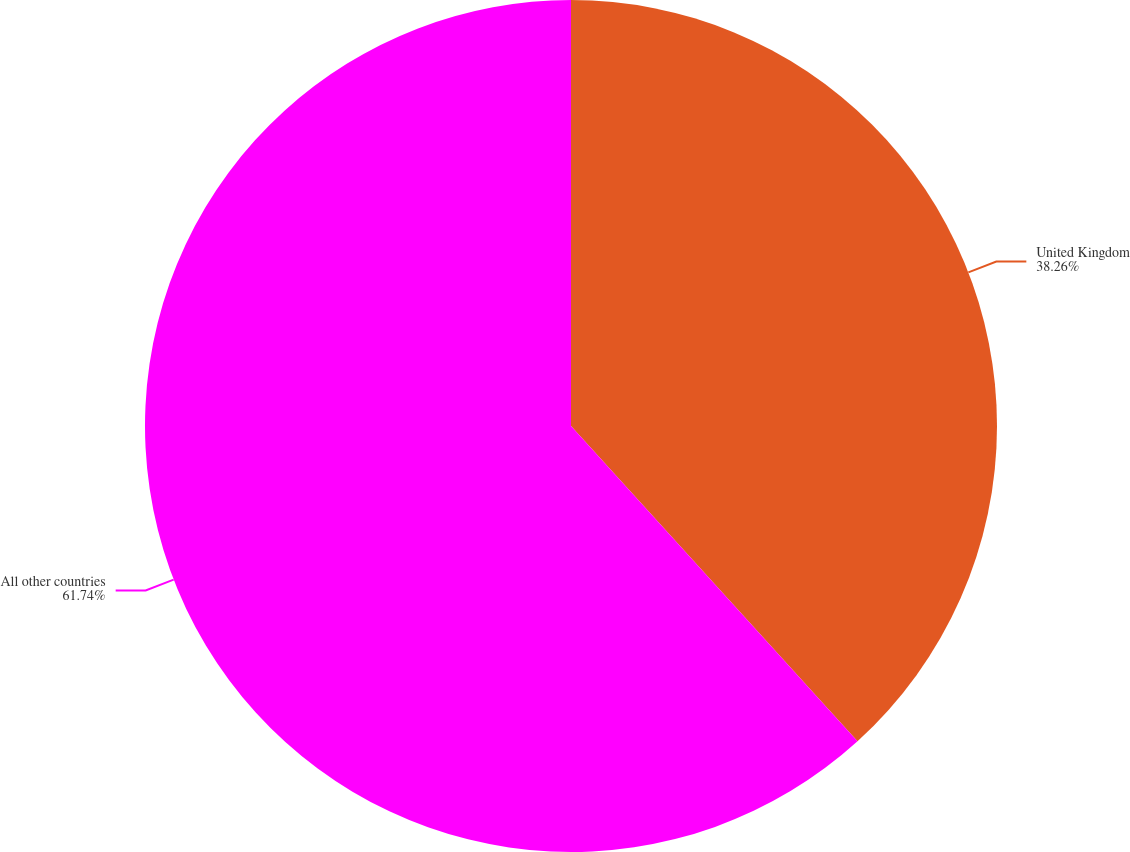Convert chart. <chart><loc_0><loc_0><loc_500><loc_500><pie_chart><fcel>United Kingdom<fcel>All other countries<nl><fcel>38.26%<fcel>61.74%<nl></chart> 